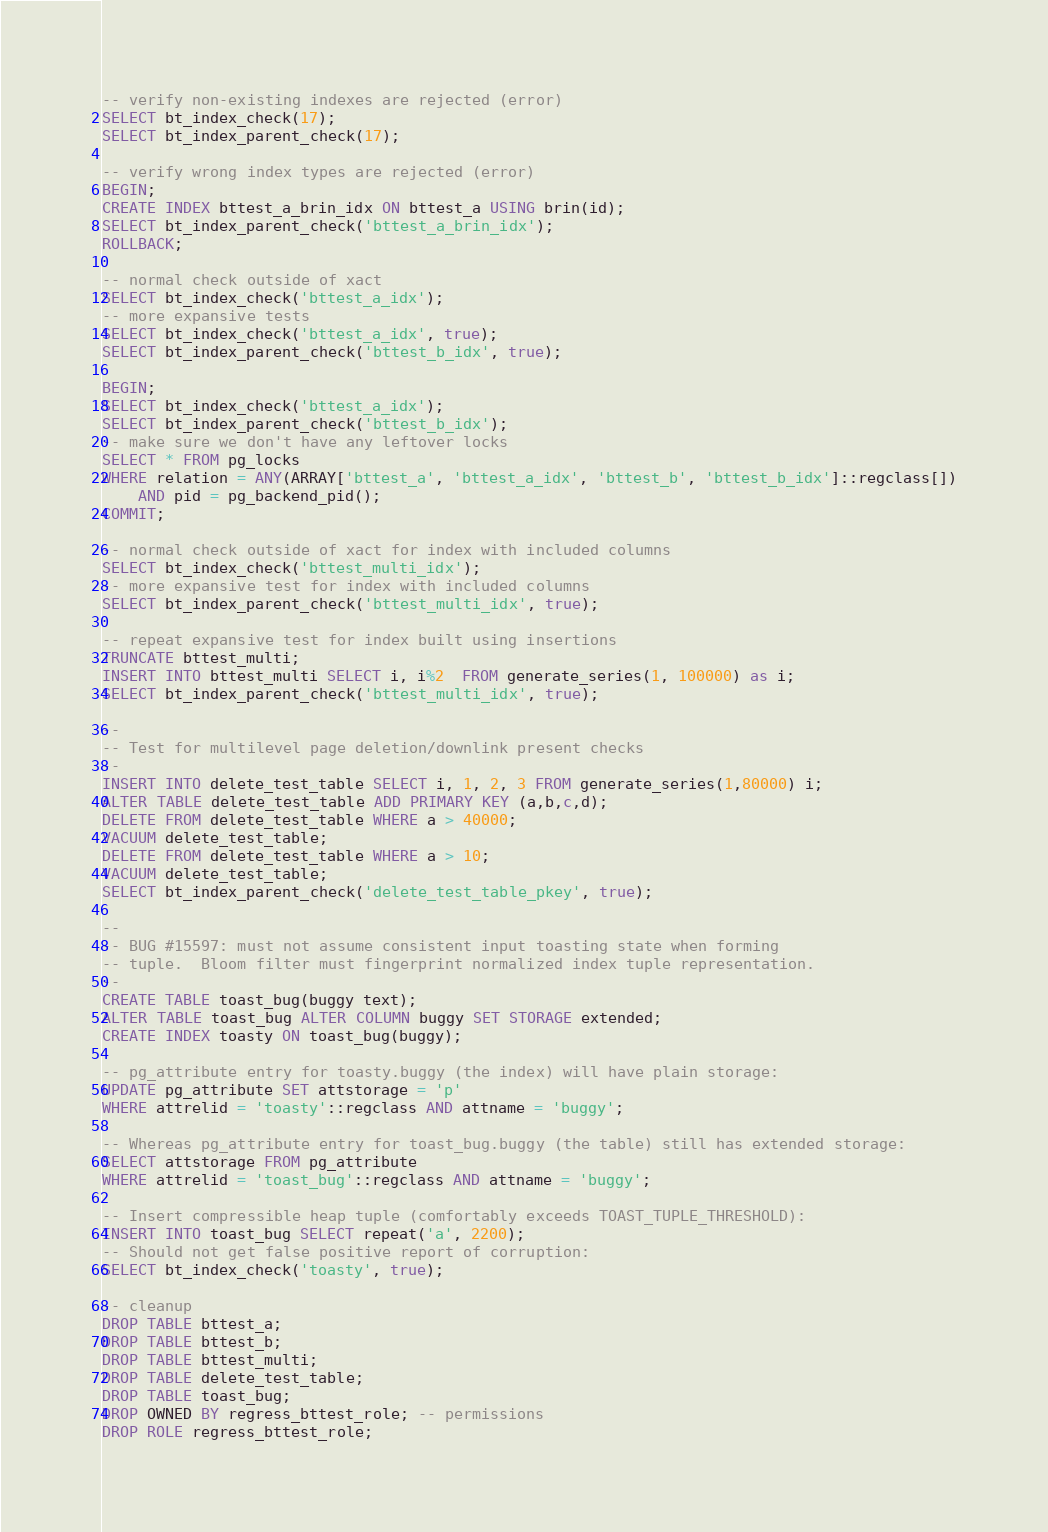Convert code to text. <code><loc_0><loc_0><loc_500><loc_500><_SQL_>-- verify non-existing indexes are rejected (error)
SELECT bt_index_check(17);
SELECT bt_index_parent_check(17);

-- verify wrong index types are rejected (error)
BEGIN;
CREATE INDEX bttest_a_brin_idx ON bttest_a USING brin(id);
SELECT bt_index_parent_check('bttest_a_brin_idx');
ROLLBACK;

-- normal check outside of xact
SELECT bt_index_check('bttest_a_idx');
-- more expansive tests
SELECT bt_index_check('bttest_a_idx', true);
SELECT bt_index_parent_check('bttest_b_idx', true);

BEGIN;
SELECT bt_index_check('bttest_a_idx');
SELECT bt_index_parent_check('bttest_b_idx');
-- make sure we don't have any leftover locks
SELECT * FROM pg_locks
WHERE relation = ANY(ARRAY['bttest_a', 'bttest_a_idx', 'bttest_b', 'bttest_b_idx']::regclass[])
    AND pid = pg_backend_pid();
COMMIT;

-- normal check outside of xact for index with included columns
SELECT bt_index_check('bttest_multi_idx');
-- more expansive test for index with included columns
SELECT bt_index_parent_check('bttest_multi_idx', true);

-- repeat expansive test for index built using insertions
TRUNCATE bttest_multi;
INSERT INTO bttest_multi SELECT i, i%2  FROM generate_series(1, 100000) as i;
SELECT bt_index_parent_check('bttest_multi_idx', true);

--
-- Test for multilevel page deletion/downlink present checks
--
INSERT INTO delete_test_table SELECT i, 1, 2, 3 FROM generate_series(1,80000) i;
ALTER TABLE delete_test_table ADD PRIMARY KEY (a,b,c,d);
DELETE FROM delete_test_table WHERE a > 40000;
VACUUM delete_test_table;
DELETE FROM delete_test_table WHERE a > 10;
VACUUM delete_test_table;
SELECT bt_index_parent_check('delete_test_table_pkey', true);

--
-- BUG #15597: must not assume consistent input toasting state when forming
-- tuple.  Bloom filter must fingerprint normalized index tuple representation.
--
CREATE TABLE toast_bug(buggy text);
ALTER TABLE toast_bug ALTER COLUMN buggy SET STORAGE extended;
CREATE INDEX toasty ON toast_bug(buggy);

-- pg_attribute entry for toasty.buggy (the index) will have plain storage:
UPDATE pg_attribute SET attstorage = 'p'
WHERE attrelid = 'toasty'::regclass AND attname = 'buggy';

-- Whereas pg_attribute entry for toast_bug.buggy (the table) still has extended storage:
SELECT attstorage FROM pg_attribute
WHERE attrelid = 'toast_bug'::regclass AND attname = 'buggy';

-- Insert compressible heap tuple (comfortably exceeds TOAST_TUPLE_THRESHOLD):
INSERT INTO toast_bug SELECT repeat('a', 2200);
-- Should not get false positive report of corruption:
SELECT bt_index_check('toasty', true);

-- cleanup
DROP TABLE bttest_a;
DROP TABLE bttest_b;
DROP TABLE bttest_multi;
DROP TABLE delete_test_table;
DROP TABLE toast_bug;
DROP OWNED BY regress_bttest_role; -- permissions
DROP ROLE regress_bttest_role;
</code> 